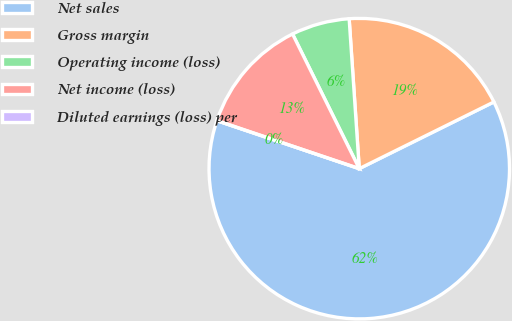Convert chart. <chart><loc_0><loc_0><loc_500><loc_500><pie_chart><fcel>Net sales<fcel>Gross margin<fcel>Operating income (loss)<fcel>Net income (loss)<fcel>Diluted earnings (loss) per<nl><fcel>62.49%<fcel>18.75%<fcel>6.25%<fcel>12.5%<fcel>0.0%<nl></chart> 